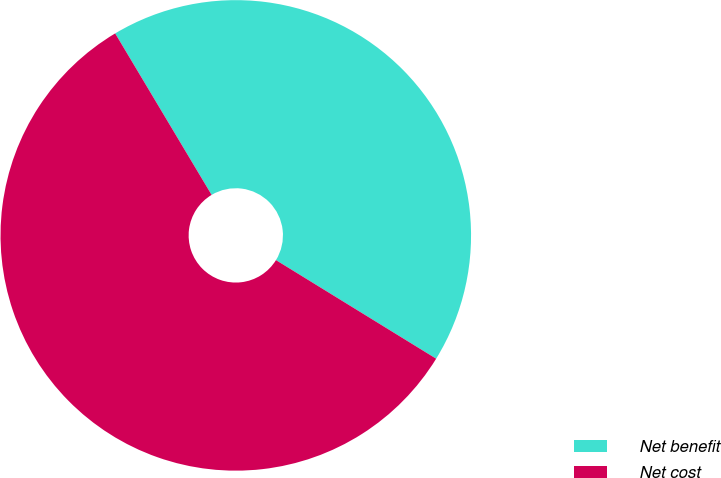Convert chart. <chart><loc_0><loc_0><loc_500><loc_500><pie_chart><fcel>Net benefit<fcel>Net cost<nl><fcel>42.35%<fcel>57.65%<nl></chart> 